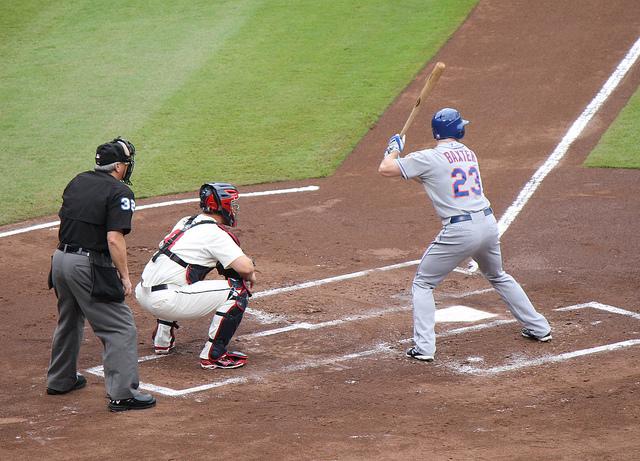What color helmet does the catcher have on?
Write a very short answer. Red. Is baseball a competitive sport?
Write a very short answer. Yes. Is the man in the black shoes going to run the bases?
Quick response, please. No. Which player is wearing the most protective gear?
Quick response, please. Catcher. 